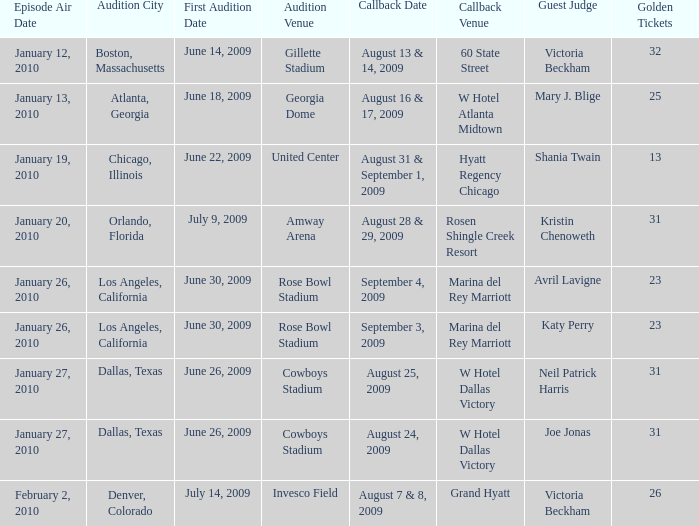Indicate the casting city for hyatt regency chicago. Chicago, Illinois. 